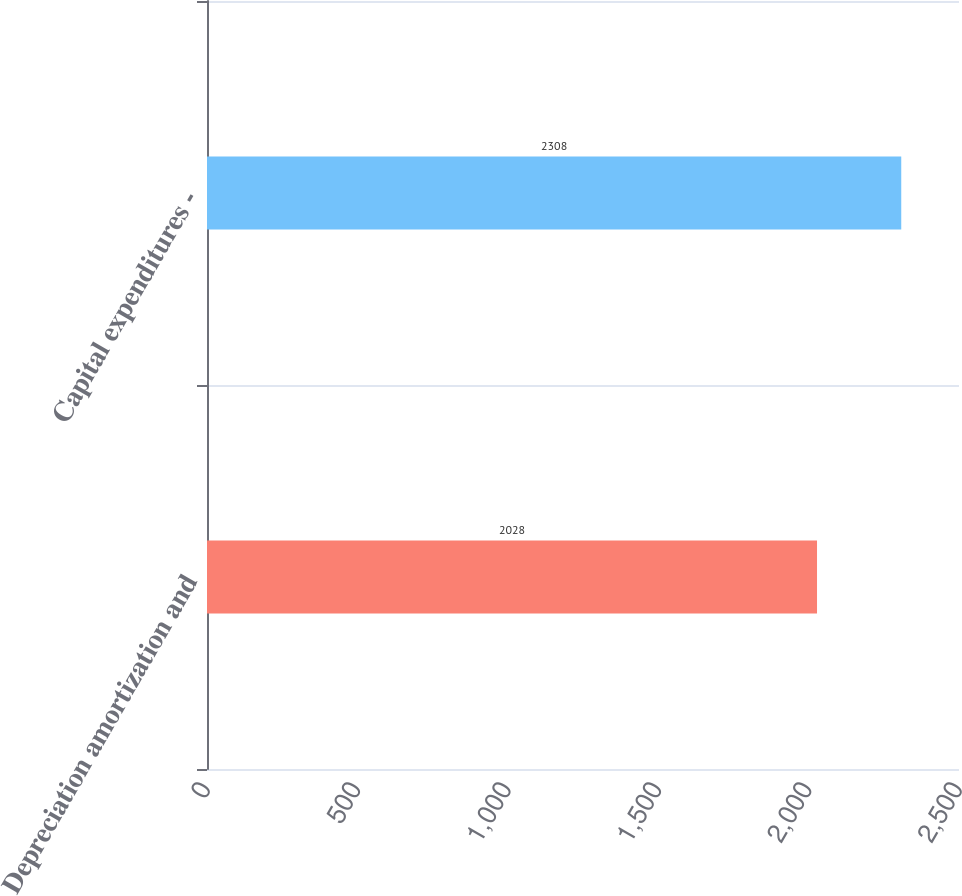Convert chart. <chart><loc_0><loc_0><loc_500><loc_500><bar_chart><fcel>Depreciation amortization and<fcel>Capital expenditures -<nl><fcel>2028<fcel>2308<nl></chart> 